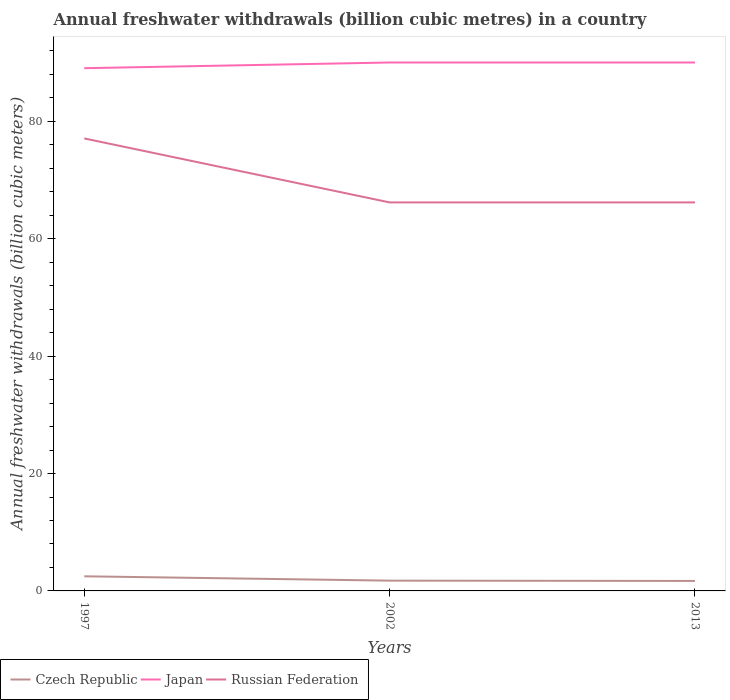How many different coloured lines are there?
Ensure brevity in your answer.  3. Is the number of lines equal to the number of legend labels?
Offer a terse response. Yes. Across all years, what is the maximum annual freshwater withdrawals in Russian Federation?
Make the answer very short. 66.2. In which year was the annual freshwater withdrawals in Czech Republic maximum?
Offer a terse response. 2013. What is the total annual freshwater withdrawals in Russian Federation in the graph?
Ensure brevity in your answer.  0. What is the difference between the highest and the second highest annual freshwater withdrawals in Russian Federation?
Offer a very short reply. 10.9. How many lines are there?
Make the answer very short. 3. Are the values on the major ticks of Y-axis written in scientific E-notation?
Offer a very short reply. No. Does the graph contain any zero values?
Your response must be concise. No. Where does the legend appear in the graph?
Your answer should be very brief. Bottom left. How are the legend labels stacked?
Your response must be concise. Horizontal. What is the title of the graph?
Offer a terse response. Annual freshwater withdrawals (billion cubic metres) in a country. What is the label or title of the X-axis?
Your response must be concise. Years. What is the label or title of the Y-axis?
Keep it short and to the point. Annual freshwater withdrawals (billion cubic meters). What is the Annual freshwater withdrawals (billion cubic meters) of Czech Republic in 1997?
Keep it short and to the point. 2.49. What is the Annual freshwater withdrawals (billion cubic meters) in Japan in 1997?
Keep it short and to the point. 89.07. What is the Annual freshwater withdrawals (billion cubic meters) of Russian Federation in 1997?
Make the answer very short. 77.1. What is the Annual freshwater withdrawals (billion cubic meters) in Czech Republic in 2002?
Provide a short and direct response. 1.75. What is the Annual freshwater withdrawals (billion cubic meters) in Japan in 2002?
Offer a very short reply. 90.04. What is the Annual freshwater withdrawals (billion cubic meters) in Russian Federation in 2002?
Provide a succinct answer. 66.2. What is the Annual freshwater withdrawals (billion cubic meters) of Czech Republic in 2013?
Make the answer very short. 1.7. What is the Annual freshwater withdrawals (billion cubic meters) in Japan in 2013?
Give a very brief answer. 90.04. What is the Annual freshwater withdrawals (billion cubic meters) in Russian Federation in 2013?
Provide a succinct answer. 66.2. Across all years, what is the maximum Annual freshwater withdrawals (billion cubic meters) in Czech Republic?
Ensure brevity in your answer.  2.49. Across all years, what is the maximum Annual freshwater withdrawals (billion cubic meters) of Japan?
Provide a short and direct response. 90.04. Across all years, what is the maximum Annual freshwater withdrawals (billion cubic meters) of Russian Federation?
Offer a very short reply. 77.1. Across all years, what is the minimum Annual freshwater withdrawals (billion cubic meters) in Czech Republic?
Your answer should be very brief. 1.7. Across all years, what is the minimum Annual freshwater withdrawals (billion cubic meters) of Japan?
Provide a succinct answer. 89.07. Across all years, what is the minimum Annual freshwater withdrawals (billion cubic meters) in Russian Federation?
Make the answer very short. 66.2. What is the total Annual freshwater withdrawals (billion cubic meters) in Czech Republic in the graph?
Give a very brief answer. 5.94. What is the total Annual freshwater withdrawals (billion cubic meters) of Japan in the graph?
Provide a short and direct response. 269.15. What is the total Annual freshwater withdrawals (billion cubic meters) in Russian Federation in the graph?
Offer a terse response. 209.5. What is the difference between the Annual freshwater withdrawals (billion cubic meters) in Czech Republic in 1997 and that in 2002?
Offer a very short reply. 0.74. What is the difference between the Annual freshwater withdrawals (billion cubic meters) in Japan in 1997 and that in 2002?
Provide a succinct answer. -0.97. What is the difference between the Annual freshwater withdrawals (billion cubic meters) in Russian Federation in 1997 and that in 2002?
Keep it short and to the point. 10.9. What is the difference between the Annual freshwater withdrawals (billion cubic meters) of Czech Republic in 1997 and that in 2013?
Your answer should be very brief. 0.79. What is the difference between the Annual freshwater withdrawals (billion cubic meters) of Japan in 1997 and that in 2013?
Your answer should be compact. -0.97. What is the difference between the Annual freshwater withdrawals (billion cubic meters) of Czech Republic in 2002 and that in 2013?
Keep it short and to the point. 0.05. What is the difference between the Annual freshwater withdrawals (billion cubic meters) in Japan in 2002 and that in 2013?
Keep it short and to the point. 0. What is the difference between the Annual freshwater withdrawals (billion cubic meters) in Russian Federation in 2002 and that in 2013?
Offer a terse response. 0. What is the difference between the Annual freshwater withdrawals (billion cubic meters) in Czech Republic in 1997 and the Annual freshwater withdrawals (billion cubic meters) in Japan in 2002?
Offer a terse response. -87.55. What is the difference between the Annual freshwater withdrawals (billion cubic meters) in Czech Republic in 1997 and the Annual freshwater withdrawals (billion cubic meters) in Russian Federation in 2002?
Provide a succinct answer. -63.71. What is the difference between the Annual freshwater withdrawals (billion cubic meters) in Japan in 1997 and the Annual freshwater withdrawals (billion cubic meters) in Russian Federation in 2002?
Keep it short and to the point. 22.87. What is the difference between the Annual freshwater withdrawals (billion cubic meters) in Czech Republic in 1997 and the Annual freshwater withdrawals (billion cubic meters) in Japan in 2013?
Make the answer very short. -87.55. What is the difference between the Annual freshwater withdrawals (billion cubic meters) in Czech Republic in 1997 and the Annual freshwater withdrawals (billion cubic meters) in Russian Federation in 2013?
Your answer should be very brief. -63.71. What is the difference between the Annual freshwater withdrawals (billion cubic meters) in Japan in 1997 and the Annual freshwater withdrawals (billion cubic meters) in Russian Federation in 2013?
Your answer should be compact. 22.87. What is the difference between the Annual freshwater withdrawals (billion cubic meters) in Czech Republic in 2002 and the Annual freshwater withdrawals (billion cubic meters) in Japan in 2013?
Your answer should be very brief. -88.29. What is the difference between the Annual freshwater withdrawals (billion cubic meters) of Czech Republic in 2002 and the Annual freshwater withdrawals (billion cubic meters) of Russian Federation in 2013?
Provide a short and direct response. -64.45. What is the difference between the Annual freshwater withdrawals (billion cubic meters) in Japan in 2002 and the Annual freshwater withdrawals (billion cubic meters) in Russian Federation in 2013?
Keep it short and to the point. 23.84. What is the average Annual freshwater withdrawals (billion cubic meters) of Czech Republic per year?
Your answer should be compact. 1.98. What is the average Annual freshwater withdrawals (billion cubic meters) in Japan per year?
Your answer should be very brief. 89.72. What is the average Annual freshwater withdrawals (billion cubic meters) in Russian Federation per year?
Provide a short and direct response. 69.83. In the year 1997, what is the difference between the Annual freshwater withdrawals (billion cubic meters) in Czech Republic and Annual freshwater withdrawals (billion cubic meters) in Japan?
Offer a very short reply. -86.58. In the year 1997, what is the difference between the Annual freshwater withdrawals (billion cubic meters) in Czech Republic and Annual freshwater withdrawals (billion cubic meters) in Russian Federation?
Give a very brief answer. -74.61. In the year 1997, what is the difference between the Annual freshwater withdrawals (billion cubic meters) in Japan and Annual freshwater withdrawals (billion cubic meters) in Russian Federation?
Offer a very short reply. 11.97. In the year 2002, what is the difference between the Annual freshwater withdrawals (billion cubic meters) in Czech Republic and Annual freshwater withdrawals (billion cubic meters) in Japan?
Give a very brief answer. -88.29. In the year 2002, what is the difference between the Annual freshwater withdrawals (billion cubic meters) of Czech Republic and Annual freshwater withdrawals (billion cubic meters) of Russian Federation?
Your answer should be very brief. -64.45. In the year 2002, what is the difference between the Annual freshwater withdrawals (billion cubic meters) in Japan and Annual freshwater withdrawals (billion cubic meters) in Russian Federation?
Ensure brevity in your answer.  23.84. In the year 2013, what is the difference between the Annual freshwater withdrawals (billion cubic meters) in Czech Republic and Annual freshwater withdrawals (billion cubic meters) in Japan?
Provide a short and direct response. -88.34. In the year 2013, what is the difference between the Annual freshwater withdrawals (billion cubic meters) of Czech Republic and Annual freshwater withdrawals (billion cubic meters) of Russian Federation?
Keep it short and to the point. -64.5. In the year 2013, what is the difference between the Annual freshwater withdrawals (billion cubic meters) in Japan and Annual freshwater withdrawals (billion cubic meters) in Russian Federation?
Make the answer very short. 23.84. What is the ratio of the Annual freshwater withdrawals (billion cubic meters) of Czech Republic in 1997 to that in 2002?
Your response must be concise. 1.42. What is the ratio of the Annual freshwater withdrawals (billion cubic meters) in Japan in 1997 to that in 2002?
Your answer should be very brief. 0.99. What is the ratio of the Annual freshwater withdrawals (billion cubic meters) in Russian Federation in 1997 to that in 2002?
Keep it short and to the point. 1.16. What is the ratio of the Annual freshwater withdrawals (billion cubic meters) of Czech Republic in 1997 to that in 2013?
Make the answer very short. 1.47. What is the ratio of the Annual freshwater withdrawals (billion cubic meters) of Japan in 1997 to that in 2013?
Provide a succinct answer. 0.99. What is the ratio of the Annual freshwater withdrawals (billion cubic meters) of Russian Federation in 1997 to that in 2013?
Ensure brevity in your answer.  1.16. What is the ratio of the Annual freshwater withdrawals (billion cubic meters) in Czech Republic in 2002 to that in 2013?
Offer a terse response. 1.03. What is the ratio of the Annual freshwater withdrawals (billion cubic meters) of Japan in 2002 to that in 2013?
Your answer should be compact. 1. What is the ratio of the Annual freshwater withdrawals (billion cubic meters) in Russian Federation in 2002 to that in 2013?
Make the answer very short. 1. What is the difference between the highest and the second highest Annual freshwater withdrawals (billion cubic meters) in Czech Republic?
Keep it short and to the point. 0.74. What is the difference between the highest and the second highest Annual freshwater withdrawals (billion cubic meters) of Japan?
Make the answer very short. 0. What is the difference between the highest and the second highest Annual freshwater withdrawals (billion cubic meters) of Russian Federation?
Ensure brevity in your answer.  10.9. What is the difference between the highest and the lowest Annual freshwater withdrawals (billion cubic meters) in Czech Republic?
Provide a short and direct response. 0.79. What is the difference between the highest and the lowest Annual freshwater withdrawals (billion cubic meters) in Japan?
Provide a short and direct response. 0.97. What is the difference between the highest and the lowest Annual freshwater withdrawals (billion cubic meters) in Russian Federation?
Your response must be concise. 10.9. 